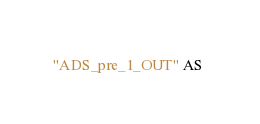<code> <loc_0><loc_0><loc_500><loc_500><_SQL_>"ADS_pre_1_OUT" AS </code> 